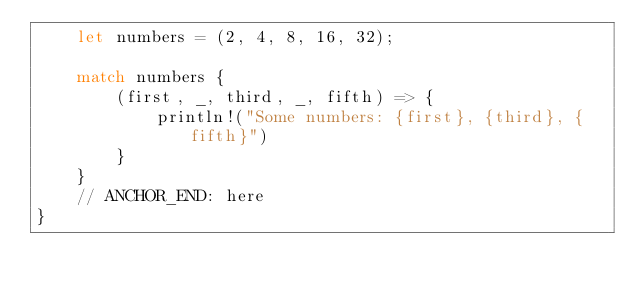<code> <loc_0><loc_0><loc_500><loc_500><_Rust_>    let numbers = (2, 4, 8, 16, 32);

    match numbers {
        (first, _, third, _, fifth) => {
            println!("Some numbers: {first}, {third}, {fifth}")
        }
    }
    // ANCHOR_END: here
}
</code> 